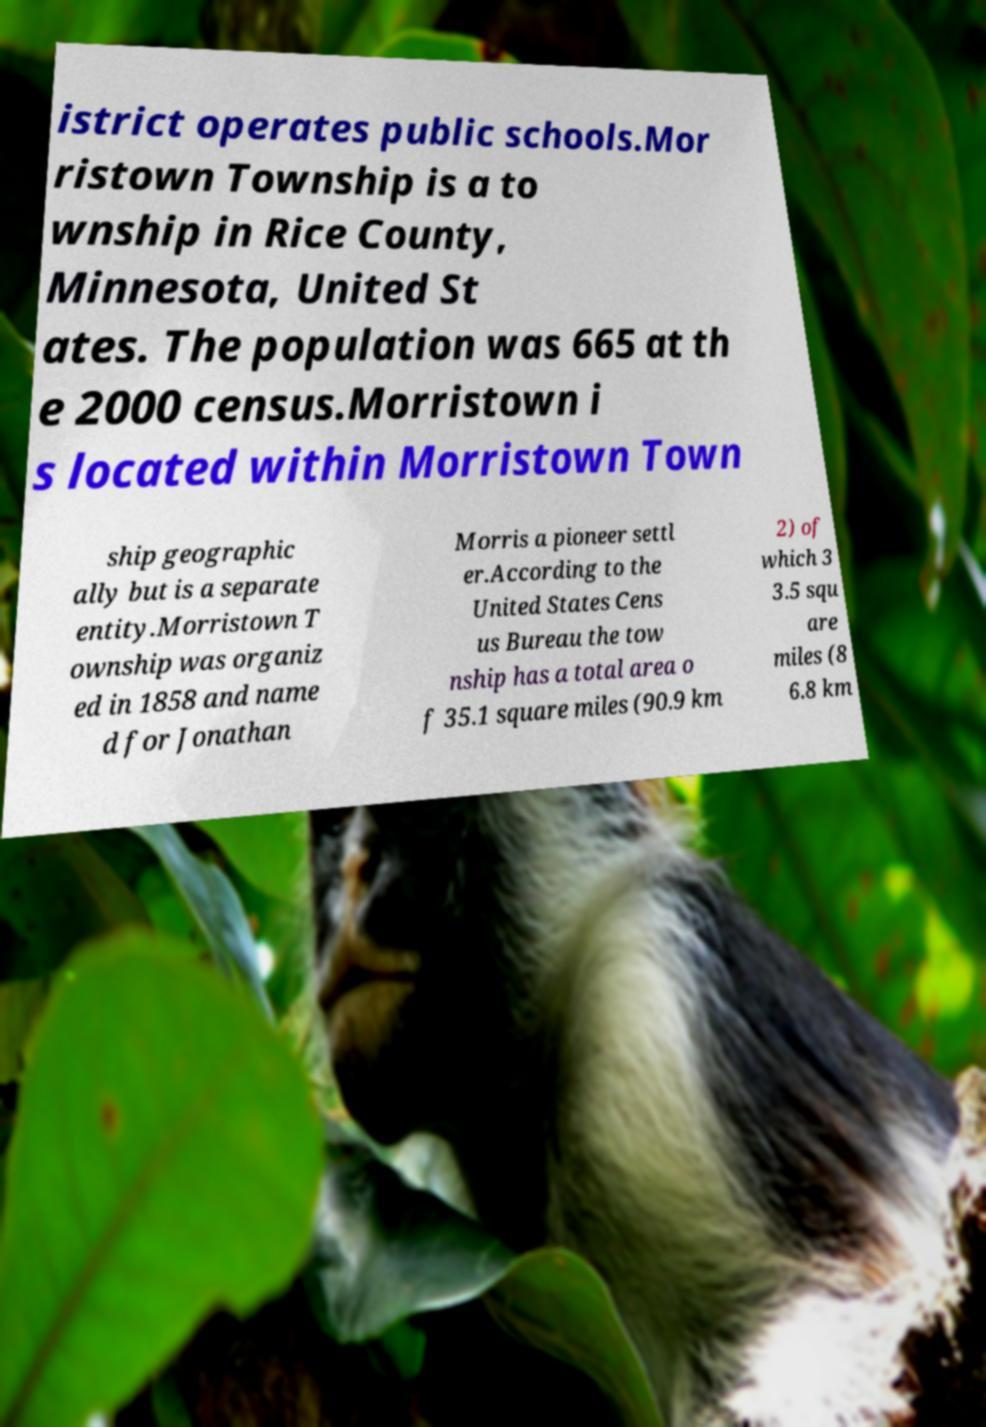Can you read and provide the text displayed in the image?This photo seems to have some interesting text. Can you extract and type it out for me? istrict operates public schools.Mor ristown Township is a to wnship in Rice County, Minnesota, United St ates. The population was 665 at th e 2000 census.Morristown i s located within Morristown Town ship geographic ally but is a separate entity.Morristown T ownship was organiz ed in 1858 and name d for Jonathan Morris a pioneer settl er.According to the United States Cens us Bureau the tow nship has a total area o f 35.1 square miles (90.9 km 2) of which 3 3.5 squ are miles (8 6.8 km 